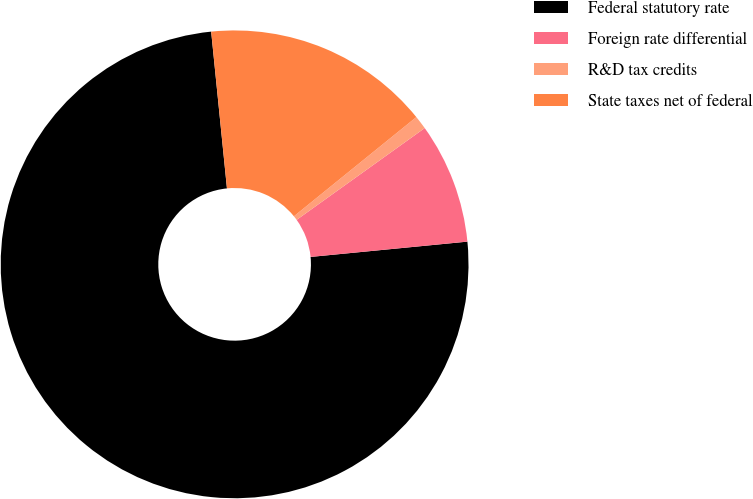Convert chart. <chart><loc_0><loc_0><loc_500><loc_500><pie_chart><fcel>Federal statutory rate<fcel>Foreign rate differential<fcel>R&D tax credits<fcel>State taxes net of federal<nl><fcel>74.95%<fcel>8.35%<fcel>0.94%<fcel>15.76%<nl></chart> 